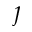<formula> <loc_0><loc_0><loc_500><loc_500>\jmath</formula> 